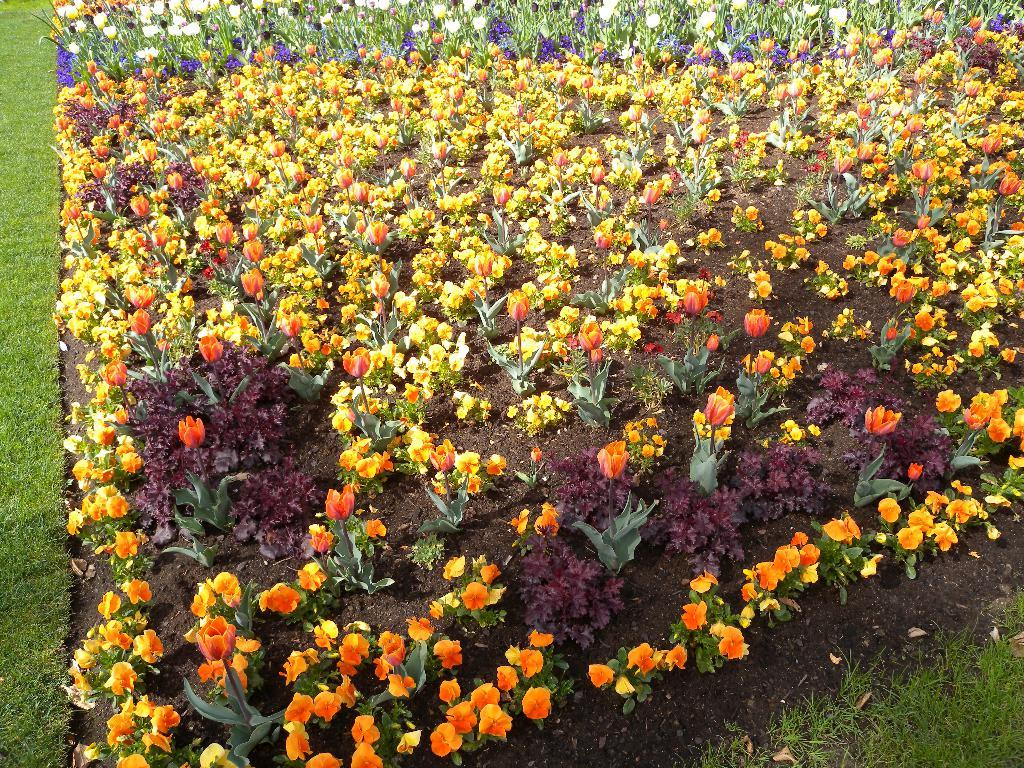What type of vegetation can be seen in the image? There are plants, grass, and flowers visible in the image. Can you describe the plants in the image? The plants in the image include grass and flowers. What type of apparel is the sister wearing while drinking wine in the image? There is no sister, apparel, or wine present in the image; it features plants, grass, and flowers. 